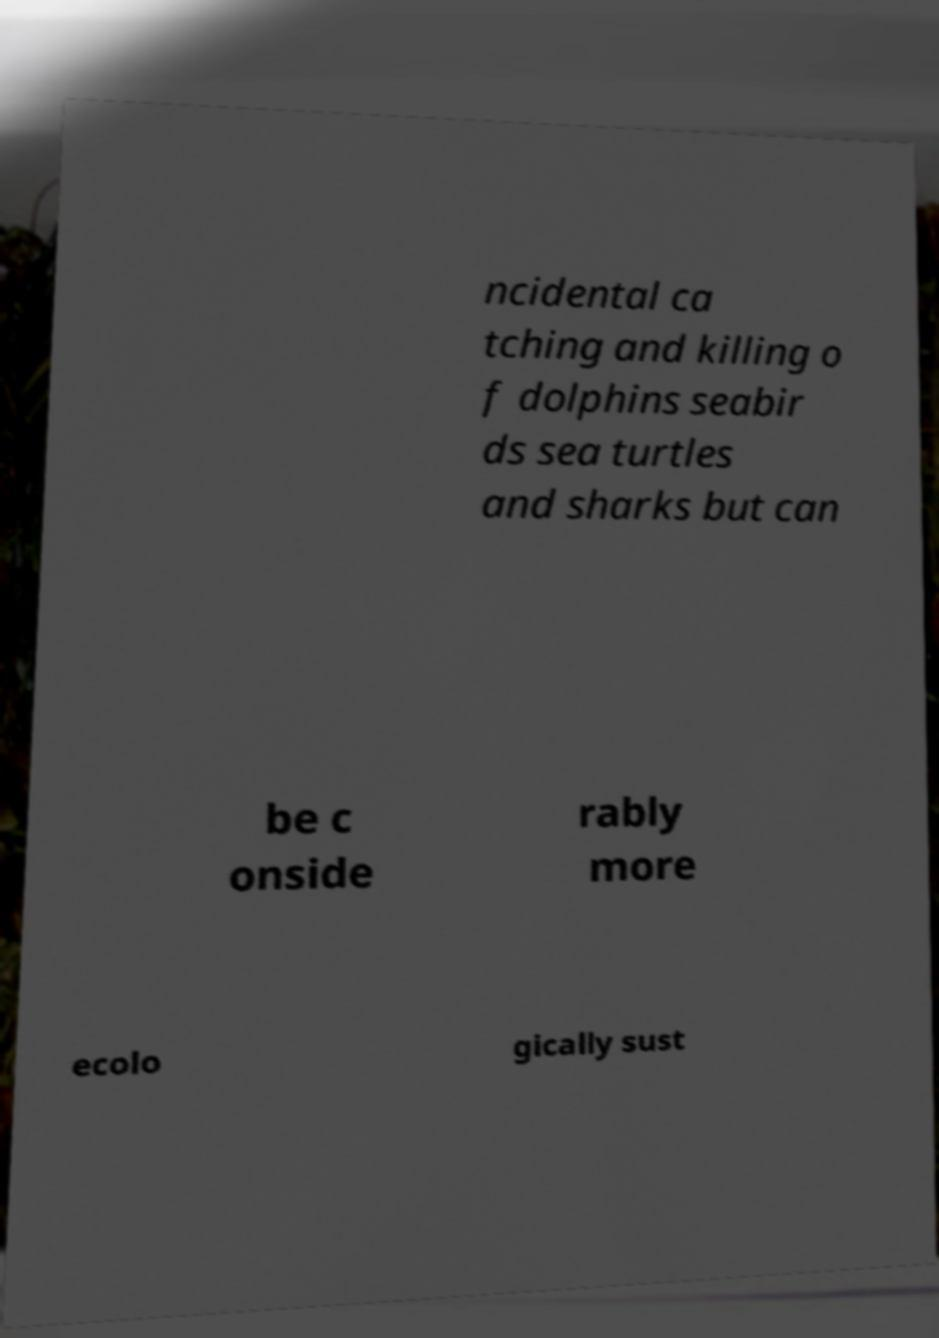I need the written content from this picture converted into text. Can you do that? ncidental ca tching and killing o f dolphins seabir ds sea turtles and sharks but can be c onside rably more ecolo gically sust 